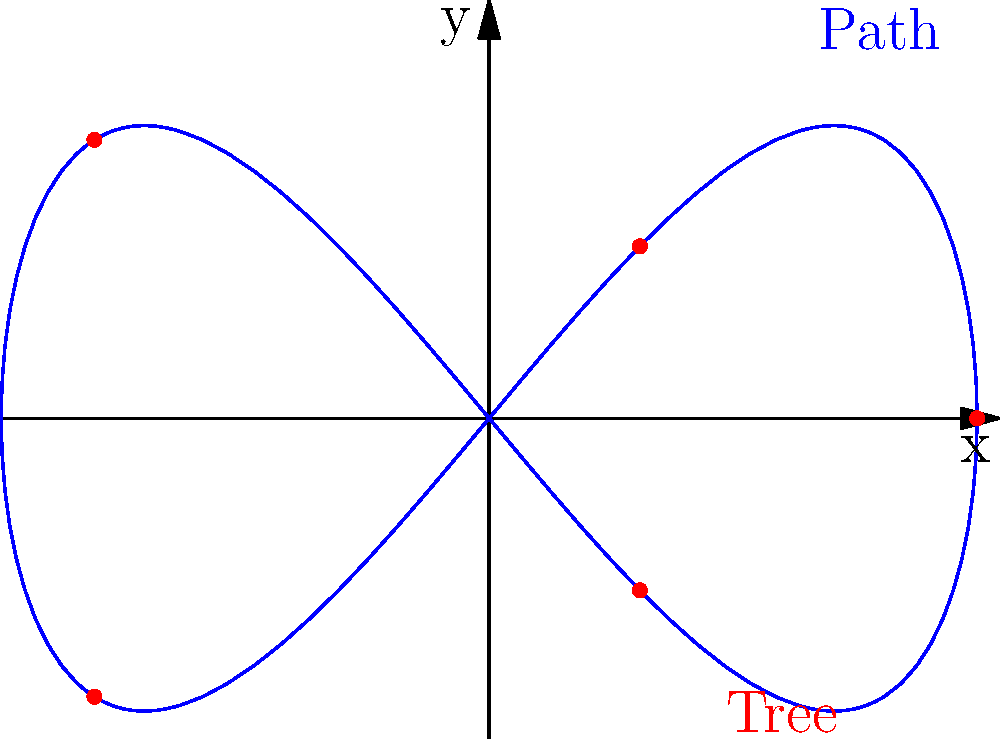A winding path in a public garden is described by the parametric equations $x = 5\cos(t)$ and $y = 3\sin(2t)$, where $0 \leq t \leq 2\pi$. To optimize the placement of trees along this path, you need to find the point where the curvature is maximum. At what $(x, y)$ coordinates should the first tree be planted? To find the point of maximum curvature, we need to follow these steps:

1) The curvature $\kappa$ for a parametric curve is given by:

   $$\kappa = \frac{|x'y'' - y'x''|}{(x'^2 + y'^2)^{3/2}}$$

2) Calculate the first derivatives:
   $x' = -5\sin(t)$
   $y' = 6\cos(2t)$

3) Calculate the second derivatives:
   $x'' = -5\cos(t)$
   $y'' = -12\sin(2t)$

4) Substitute these into the curvature formula:

   $$\kappa = \frac{|-5\sin(t)(-12\sin(2t)) - 6\cos(2t)(-5\cos(t))|}{(25\sin^2(t) + 36\cos^2(2t))^{3/2}}$$

5) Simplify:

   $$\kappa = \frac{|60\sin(t)\sin(2t) + 30\cos(t)\cos(2t)|}{(25\sin^2(t) + 36\cos^2(2t))^{3/2}}$$

6) The curvature is maximum when $t = \frac{\pi}{2}$ or $t = \frac{3\pi}{2}$. We can verify this by plotting the curvature function.

7) When $t = \frac{\pi}{2}$:
   $x = 5\cos(\frac{\pi}{2}) = 0$
   $y = 3\sin(2\cdot\frac{\pi}{2}) = 3\sin(\pi) = 0$

8) When $t = \frac{3\pi}{2}$:
   $x = 5\cos(\frac{3\pi}{2}) = 0$
   $y = 3\sin(2\cdot\frac{3\pi}{2}) = 3\sin(3\pi) = 0$

Both points give the same coordinates (0, 0), which is the center of the curve.
Answer: (0, 0) 